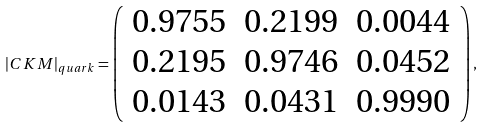<formula> <loc_0><loc_0><loc_500><loc_500>| C K M | _ { q u a r k } = \left ( \begin{array} { c c c } 0 . 9 7 5 5 & 0 . 2 1 9 9 & 0 . 0 0 4 4 \\ 0 . 2 1 9 5 & 0 . 9 7 4 6 & 0 . 0 4 5 2 \\ 0 . 0 1 4 3 & 0 . 0 4 3 1 & 0 . 9 9 9 0 \end{array} \right ) ,</formula> 